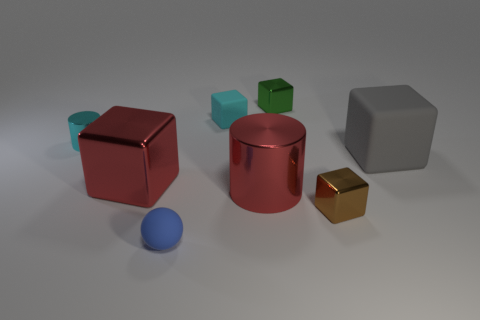How many things are things behind the gray thing or big red things that are on the right side of the small blue sphere?
Offer a terse response. 4. There is a blue thing that is the same size as the green shiny block; what shape is it?
Provide a short and direct response. Sphere. There is a tiny matte object that is behind the large red object on the right side of the matte block that is on the left side of the large shiny cylinder; what shape is it?
Make the answer very short. Cube. Is the number of small spheres behind the big gray block the same as the number of blue rubber balls?
Your answer should be compact. No. Do the green shiny object and the brown shiny object have the same size?
Your answer should be very brief. Yes. What number of metallic things are either red cylinders or red spheres?
Keep it short and to the point. 1. What is the material of the green block that is the same size as the matte sphere?
Provide a succinct answer. Metal. How many other objects are the same material as the cyan block?
Your response must be concise. 2. Are there fewer small matte blocks that are behind the tiny cyan matte object than small cyan rubber blocks?
Your answer should be compact. Yes. Is the shape of the green shiny thing the same as the large gray matte thing?
Your answer should be very brief. Yes. 